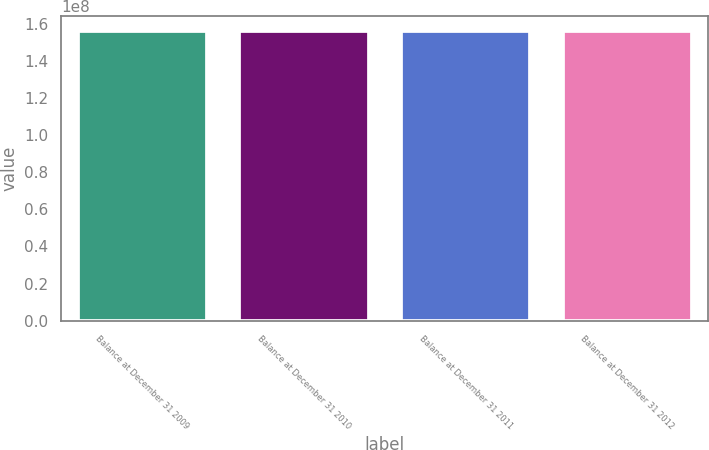<chart> <loc_0><loc_0><loc_500><loc_500><bar_chart><fcel>Balance at December 31 2009<fcel>Balance at December 31 2010<fcel>Balance at December 31 2011<fcel>Balance at December 31 2012<nl><fcel>1.56234e+08<fcel>1.56234e+08<fcel>1.56234e+08<fcel>1.56234e+08<nl></chart> 